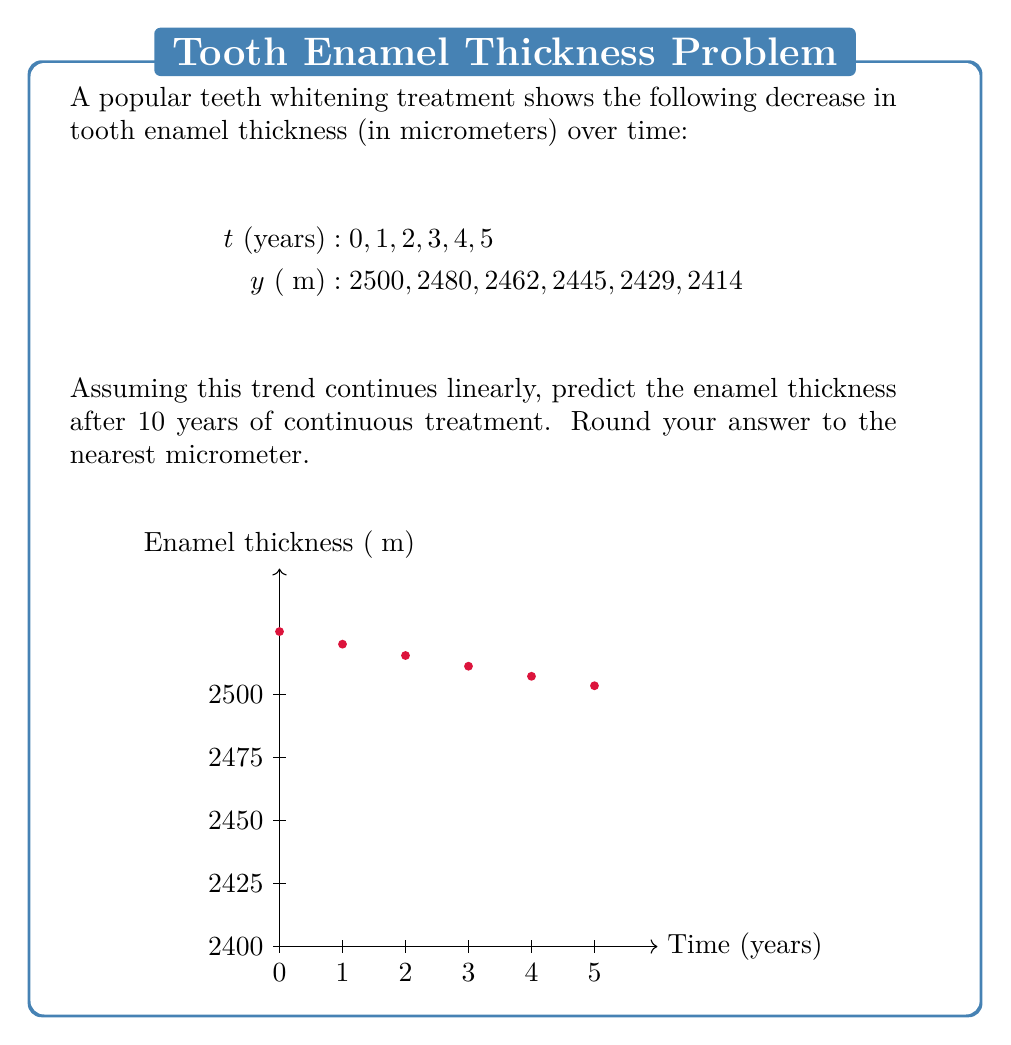Teach me how to tackle this problem. To predict the enamel thickness after 10 years, we need to perform a linear regression analysis on the given data:

1. Calculate the slope (m) of the linear trend:
   $$m = \frac{\sum_{i=1}^n (x_i - \bar{x})(y_i - \bar{y})}{\sum_{i=1}^n (x_i - \bar{x})^2}$$

   Where:
   $\bar{x} = \frac{\sum_{i=1}^n x_i}{n} = \frac{0+1+2+3+4+5}{6} = 2.5$
   $\bar{y} = \frac{\sum_{i=1}^n y_i}{n} = \frac{2500+2480+2462+2445+2429+2414}{6} = 2455$

2. Calculating the numerator and denominator:
   $\sum_{i=1}^n (x_i - \bar{x})(y_i - \bar{y}) = -1050$
   $\sum_{i=1}^n (x_i - \bar{x})^2 = 17.5$

3. Slope:
   $$m = \frac{-1050}{17.5} = -60$$

4. Calculate the y-intercept (b):
   $$b = \bar{y} - m\bar{x} = 2455 - (-60 \cdot 2.5) = 2605$$

5. The linear equation is:
   $$y = mx + b = -60x + 2605$$

6. Predict the enamel thickness at t = 10 years:
   $$y = -60 \cdot 10 + 2605 = 2005$$

Therefore, the predicted enamel thickness after 10 years of continuous treatment is 2005 micrometers.
Answer: 2005 μm 